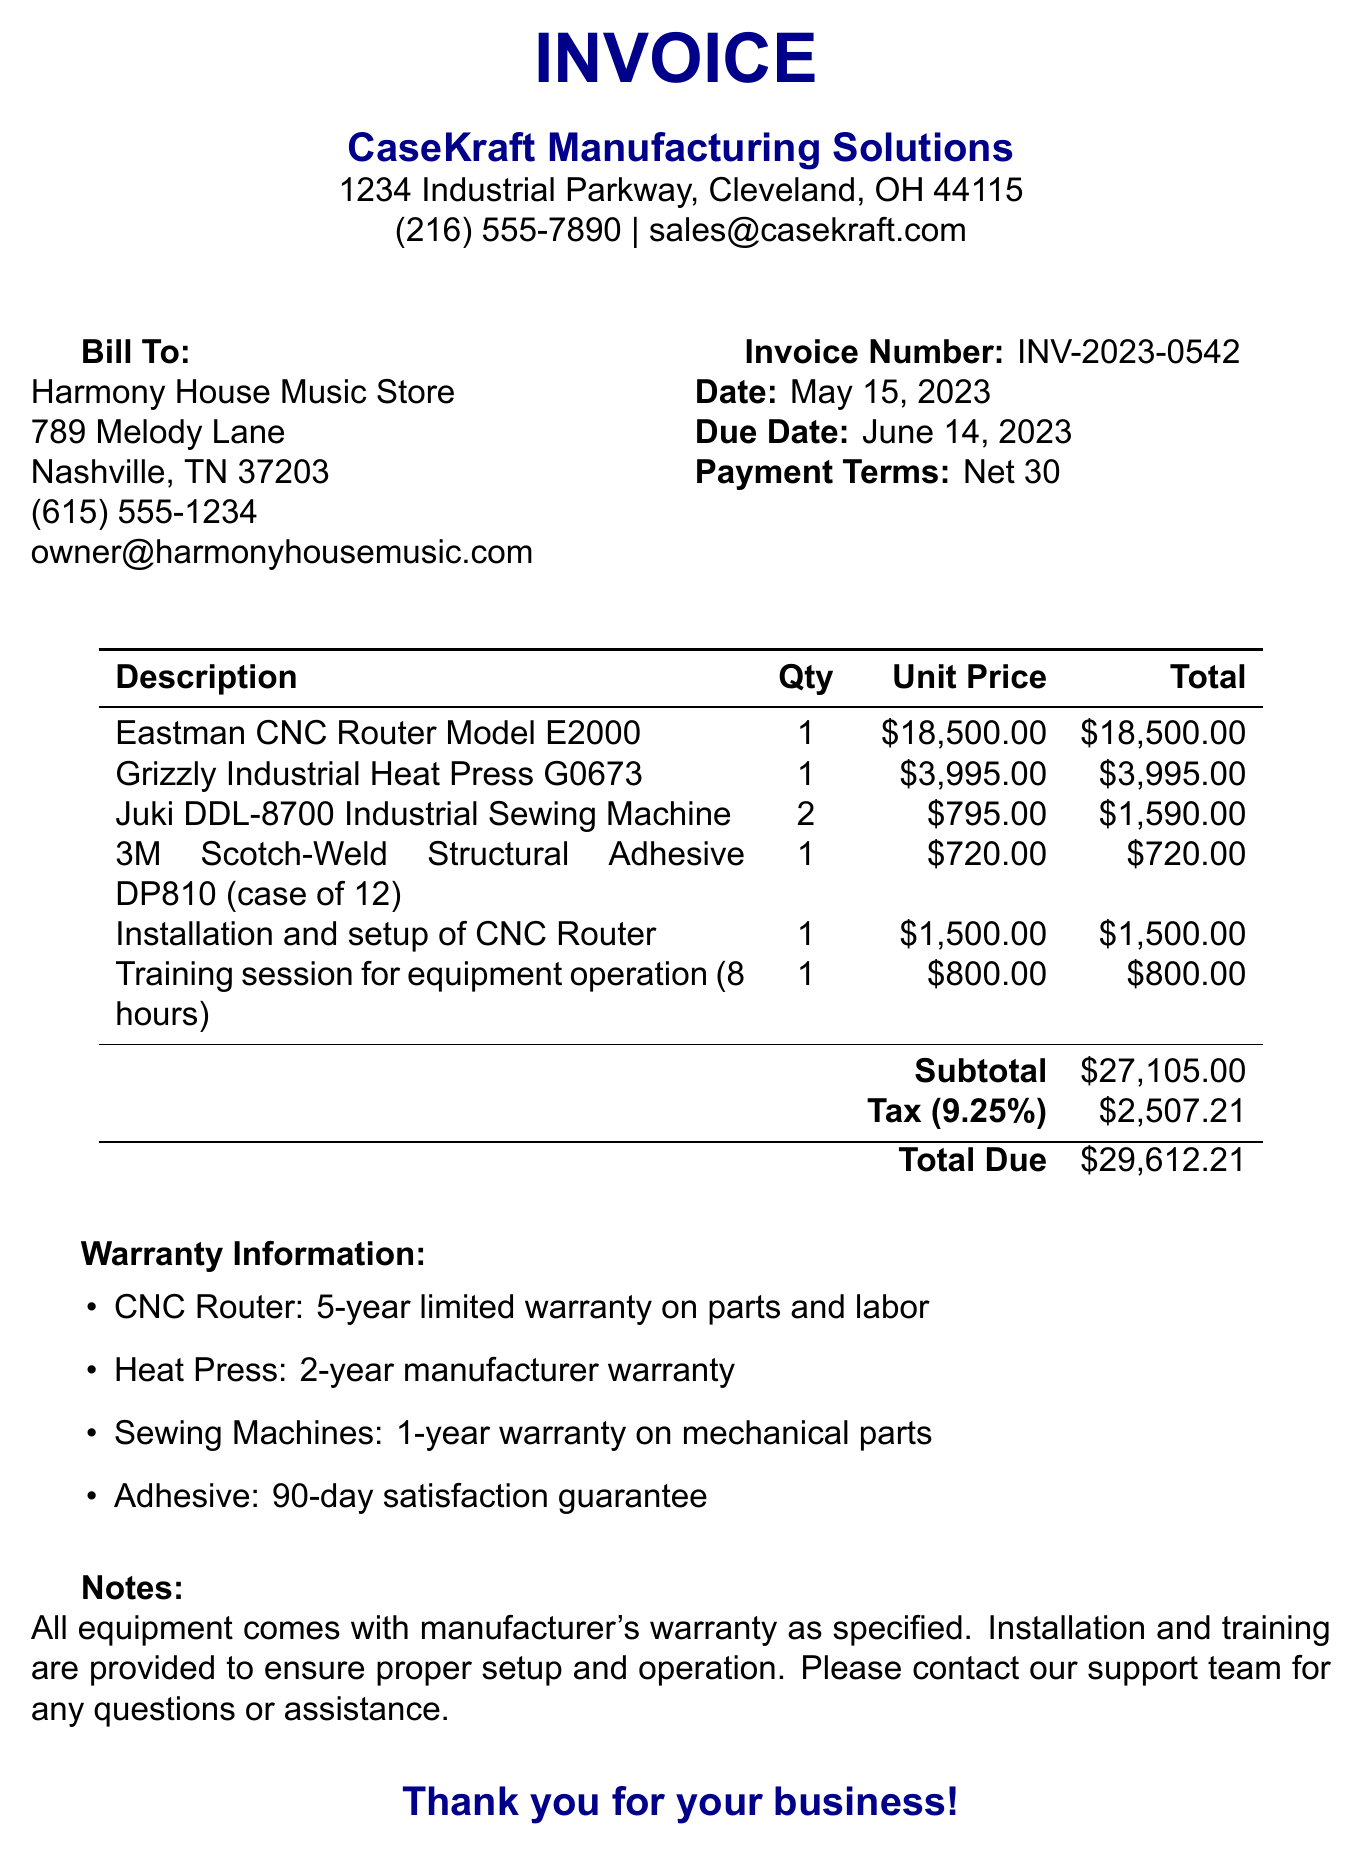What is the invoice number? The invoice number is specifically mentioned in the document, identifying this transaction.
Answer: INV-2023-0542 Who is the seller? The seller's name appears at the top of the invoice, indicating the company selling the equipment.
Answer: CaseKraft Manufacturing Solutions What is the total amount due? The total amount due is summed up at the bottom of the invoice, representing the total cost.
Answer: $29,612.21 How many Juki DDL-8700 Industrial Sewing Machines were purchased? The quantity of sewing machines is recorded in the items section, specifying how many were ordered.
Answer: 2 What is the warranty period for the CNC Router? The warranty information section lists the specific warranty period for each item, including the CNC Router.
Answer: 5-year limited warranty What is the tax rate applied to the invoice? The tax rate is indicated clearly in the document, applied to the subtotal.
Answer: 9.25% What training is included in the purchase? The specific training session provided is detailed in the items section of the invoice.
Answer: Training session for equipment operation (8 hours) What is the due date for payment? The due date is stated in the document, indicating when payment is expected.
Answer: June 14, 2023 What is included in the notes section? The notes section contains additional information about warranties and support for the buyer.
Answer: All equipment comes with manufacturer's warranty as specified 